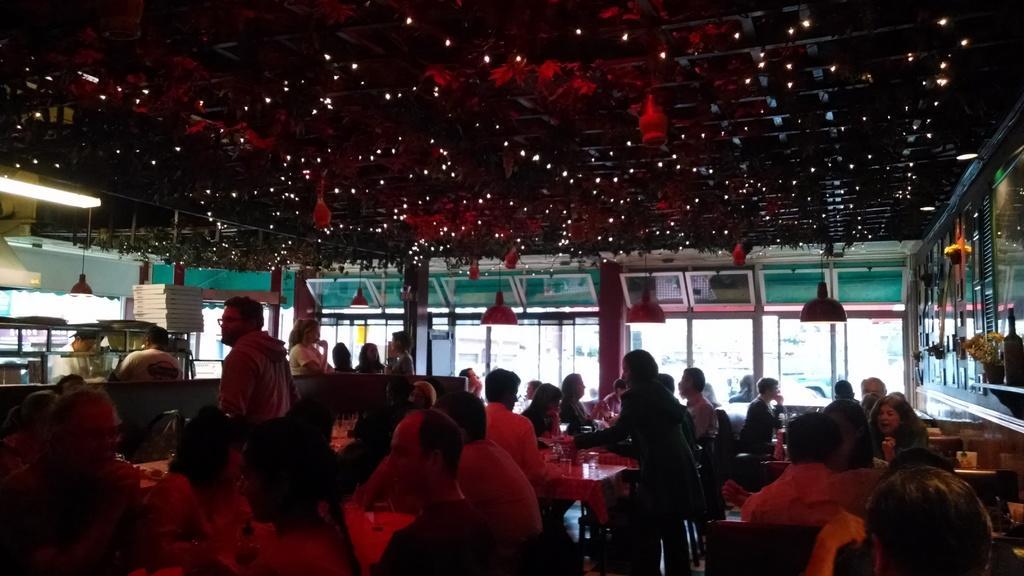In one or two sentences, can you explain what this image depicts? In this picture we can see many people were sitting inside the hotel, beside them we can see the table and chairs. And some peoples were sitting on the bench. On the left there is a man who is wearing white dress, he is standing behind the kitchen platform. At the top we can see the lights and decoration materials. Through the doors we can see other buildings. On the right we can see some glasses. 